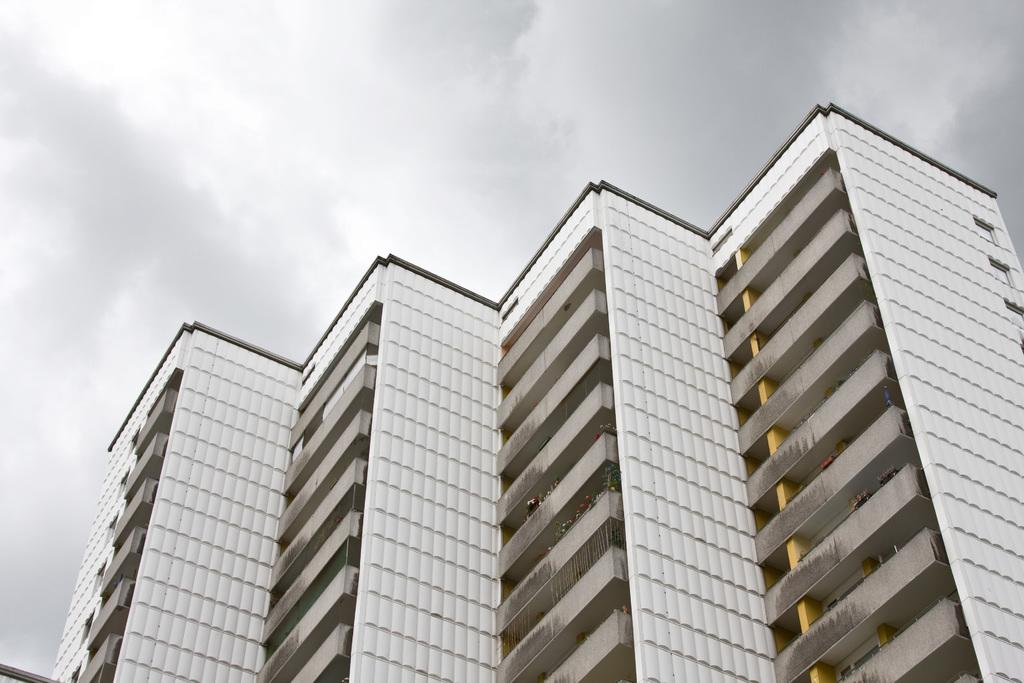What is the main subject in the center of the image? There are buildings in the center of the image. What can be seen at the top of the image? The sky is visible at the top of the image. How many guides are present in the image? There is no mention of guides in the image, so it cannot be determined how many are present. 